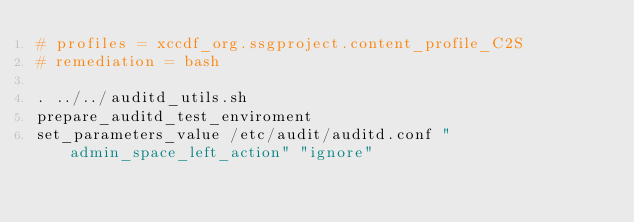Convert code to text. <code><loc_0><loc_0><loc_500><loc_500><_Bash_># profiles = xccdf_org.ssgproject.content_profile_C2S
# remediation = bash

. ../../auditd_utils.sh
prepare_auditd_test_enviroment
set_parameters_value /etc/audit/auditd.conf "admin_space_left_action" "ignore"
</code> 